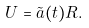Convert formula to latex. <formula><loc_0><loc_0><loc_500><loc_500>U = \tilde { a } ( t ) R .</formula> 